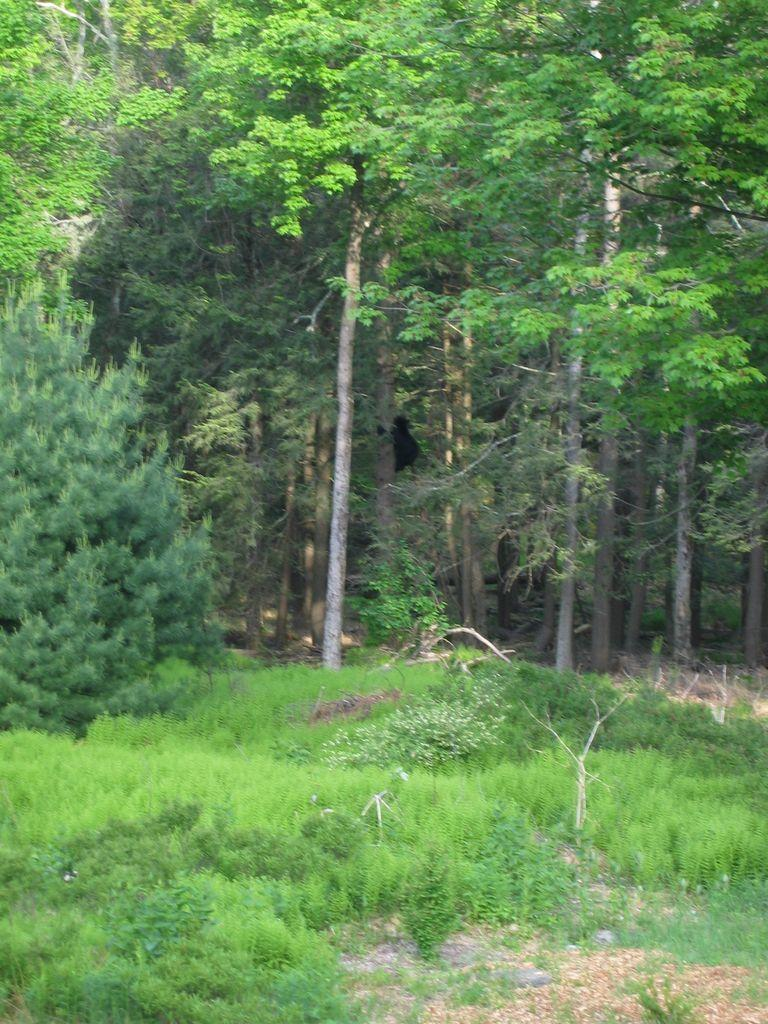What type of vegetation can be seen in the image? There is grass, plants, and trees in the image. Can you describe the natural environment depicted in the image? The image features a variety of vegetation, including grass, plants, and trees. How many dinosaurs are playing with the plants in the image? There are no dinosaurs present in the image; it features only vegetation. What type of cord is used to connect the sisters in the image? There are no sisters or cords present in the image; it features only vegetation. 